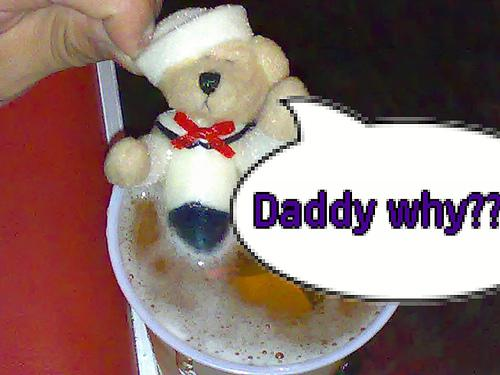Question: why is there text on the screen?
Choices:
A. It was added.
B. It is the closed caption.
C. For the hearing impaired.
D. For the meeting.
Answer with the letter. Answer: A Question: what is this a picture of?
Choices:
A. The skyline.
B. The ocean.
C. A bear.
D. The moon.
Answer with the letter. Answer: C 